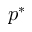Convert formula to latex. <formula><loc_0><loc_0><loc_500><loc_500>p ^ { * }</formula> 